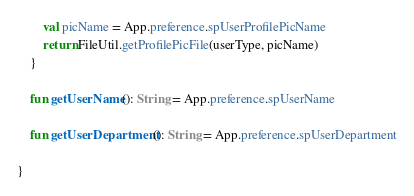Convert code to text. <code><loc_0><loc_0><loc_500><loc_500><_Kotlin_>        val picName = App.preference.spUserProfilePicName
        return FileUtil.getProfilePicFile(userType, picName)
    }

    fun getUserName(): String = App.preference.spUserName

    fun getUserDepartment(): String = App.preference.spUserDepartment

}
</code> 